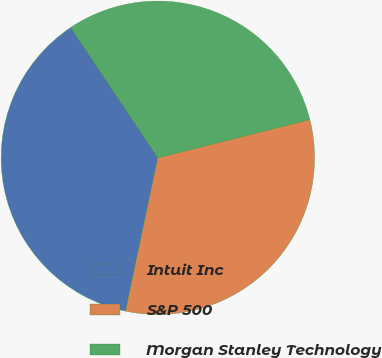Convert chart to OTSL. <chart><loc_0><loc_0><loc_500><loc_500><pie_chart><fcel>Intuit Inc<fcel>S&P 500<fcel>Morgan Stanley Technology<nl><fcel>37.32%<fcel>32.23%<fcel>30.45%<nl></chart> 